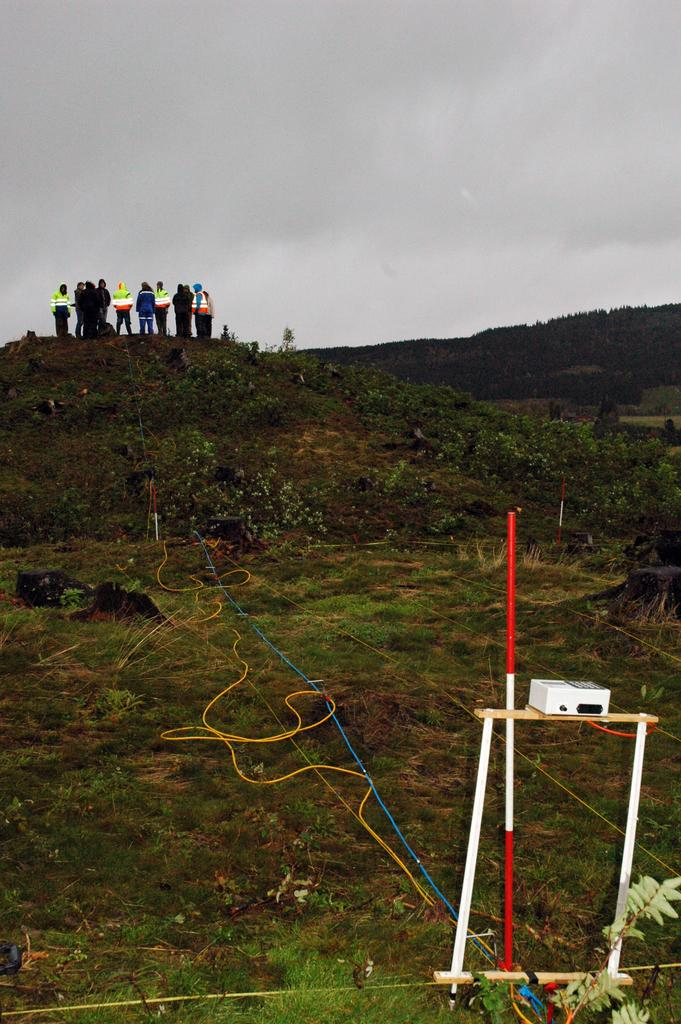What is happening on the hill in the image? There are persons on the hill in the image. What objects can be seen at the bottom right corner of the image? There is a projector and a pole at the bottom right corner of the image. What can be seen in the background of the image? The sky is visible in the background of the image. What type of country is depicted on the table in the image? There is no table or country present in the image. How many knots are tied on the pole in the image? There is no mention of knots on the pole in the image; it is simply a pole. 